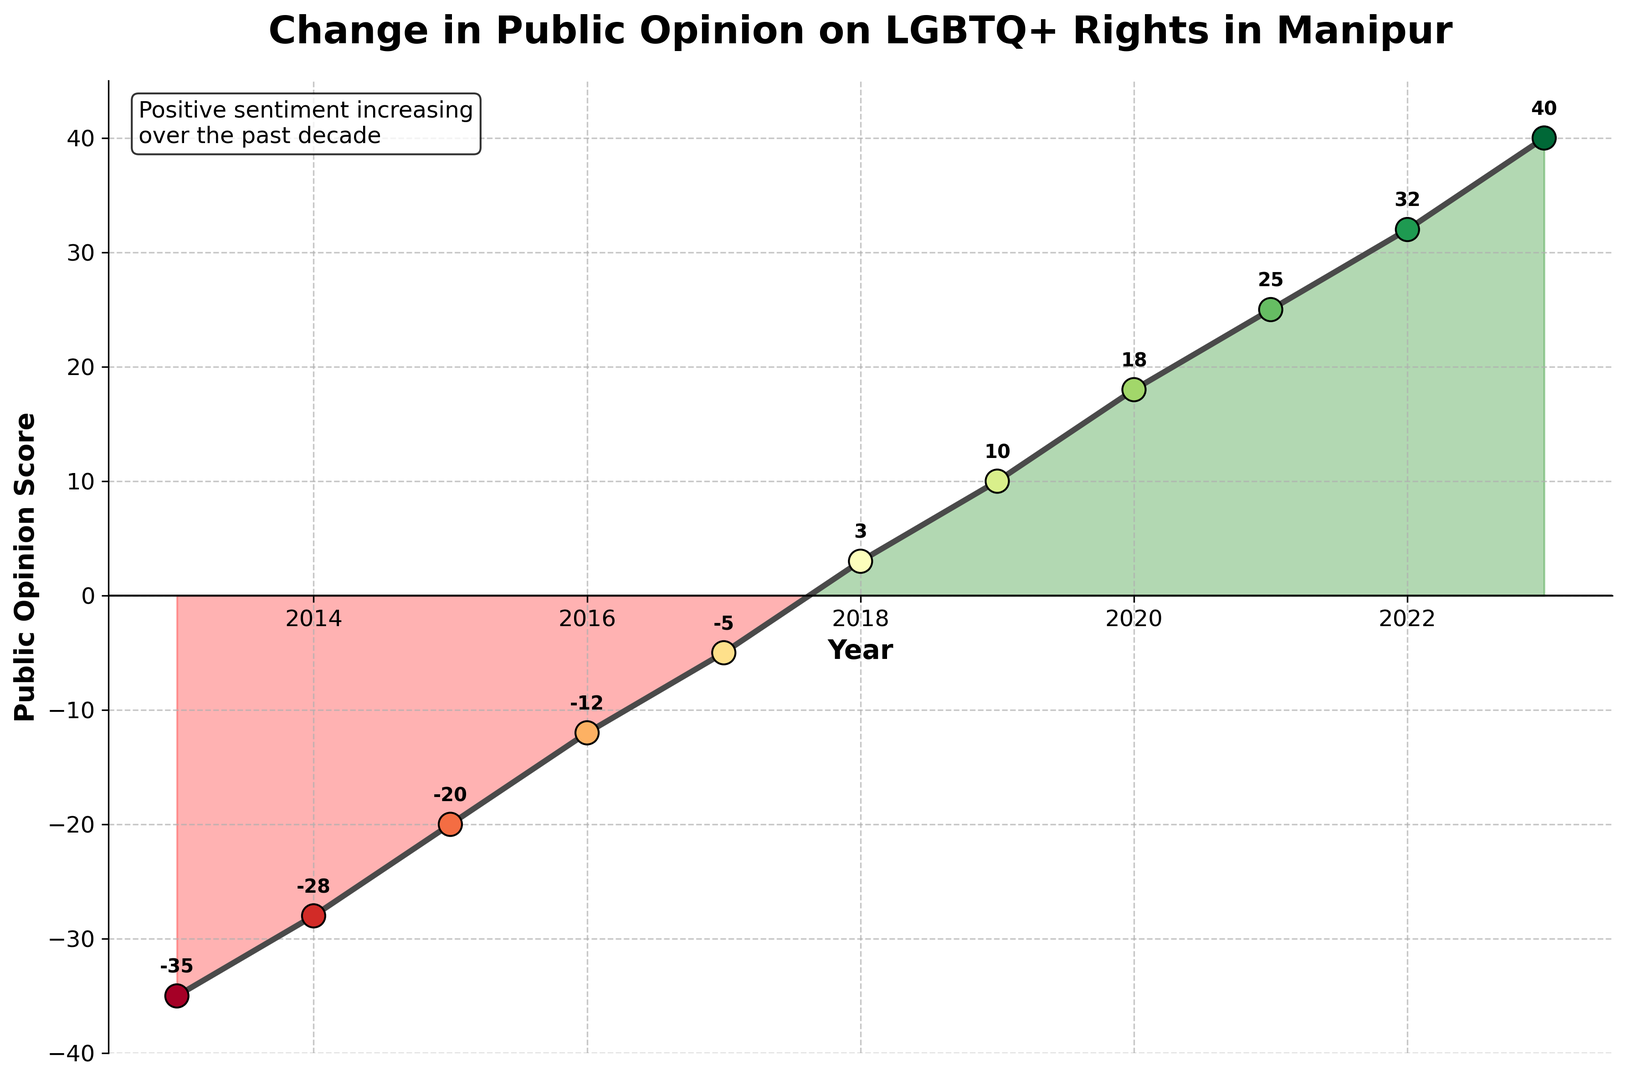How has public opinion on LGBTQ+ rights changed from 2013 to 2019? Look at the plot. In 2013, the public opinion score was -35, and it increased to 10 in 2019. Thus, the public opinion improved from negative to positive.
Answer: Improved by 45 points What was the lowest public opinion score recorded and in which year? Look at the plot to find the lowest point (most negative value) on the y-axis. The lowest score is -35, recorded in 2013.
Answer: -35 in 2013 In which years did the public opinion score become positive for the first time? Identify the first year where the score crosses the x-axis (from negative to positive). In 2018, the score was 3, which marked the first positive value.
Answer: 2018 What is the difference in public opinion score between 2015 and 2020? Look at the scores for 2015 and 2020, which are -20 and 18, respectively. Calculate the difference: 18 - (-20) = 38.
Answer: 38 points Which year showed the most significant improvement in public opinion compared to the previous year? Compare the yearly changes. The largest positive jump occurs between 2017 and 2018, where the score went from -5 to 3. The improvement is 3 - (-5) = 8 points.
Answer: 2018 How many years had a negative public opinion score? Count the number of years where the score is below the x-axis (negative values). These years are 2013 to 2017.
Answer: 5 years What was the public opinion score in 2022, and how did it compare to the previous year? Look at the scores for 2022 and 2021, which are 32 and 25, respectively. The difference is 32 - 25 = 7.
Answer: 32, improved by 7 points Is there a trend after 2018 that shows consistent improvement or deterioration in public sentiment? Observe the plot from 2018 onwards. The scores continuously improve every year from 2018 (3) to 2023 (40).
Answer: Consistent improvement How much did public opinion improve from 2013 to 2023? Calculate the difference between the scores in 2023 and 2013, which are 40 and -35, respectively. The difference is 40 - (-35) = 75.
Answer: Improved by 75 points Which year had nearly neutral (close to zero) public opinion? Look at the plot for the year where the score is closest to zero. In 2018, the score was 3, which is closest to neutral.
Answer: 2018 